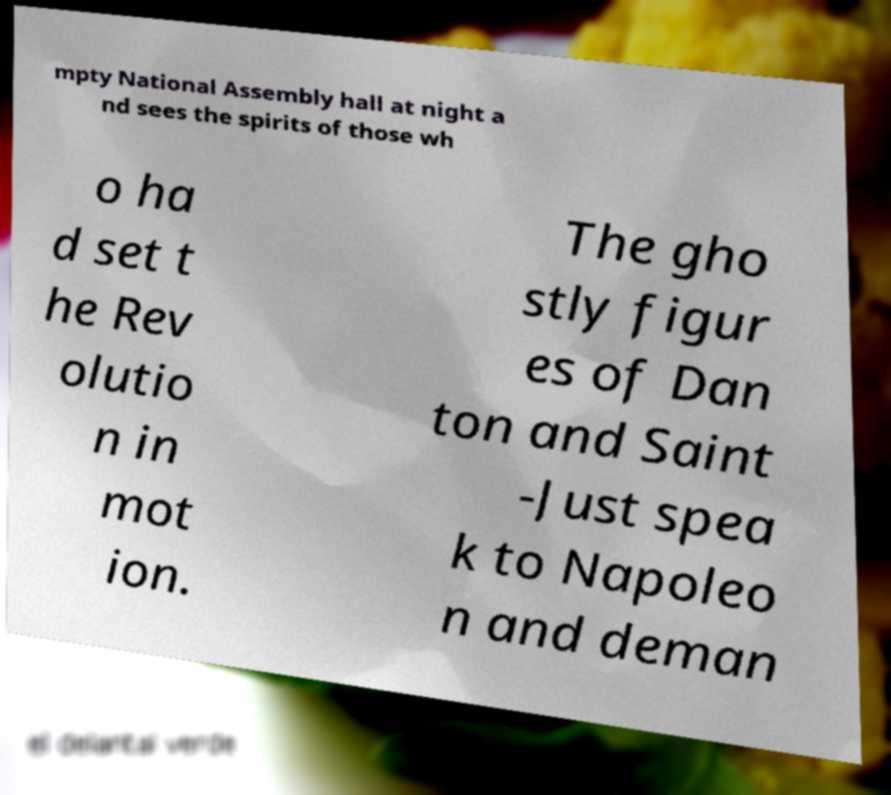Please read and relay the text visible in this image. What does it say? mpty National Assembly hall at night a nd sees the spirits of those wh o ha d set t he Rev olutio n in mot ion. The gho stly figur es of Dan ton and Saint -Just spea k to Napoleo n and deman 